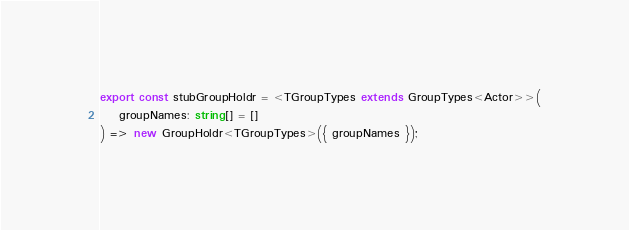<code> <loc_0><loc_0><loc_500><loc_500><_TypeScript_>export const stubGroupHoldr = <TGroupTypes extends GroupTypes<Actor>>(
    groupNames: string[] = []
) => new GroupHoldr<TGroupTypes>({ groupNames });
</code> 